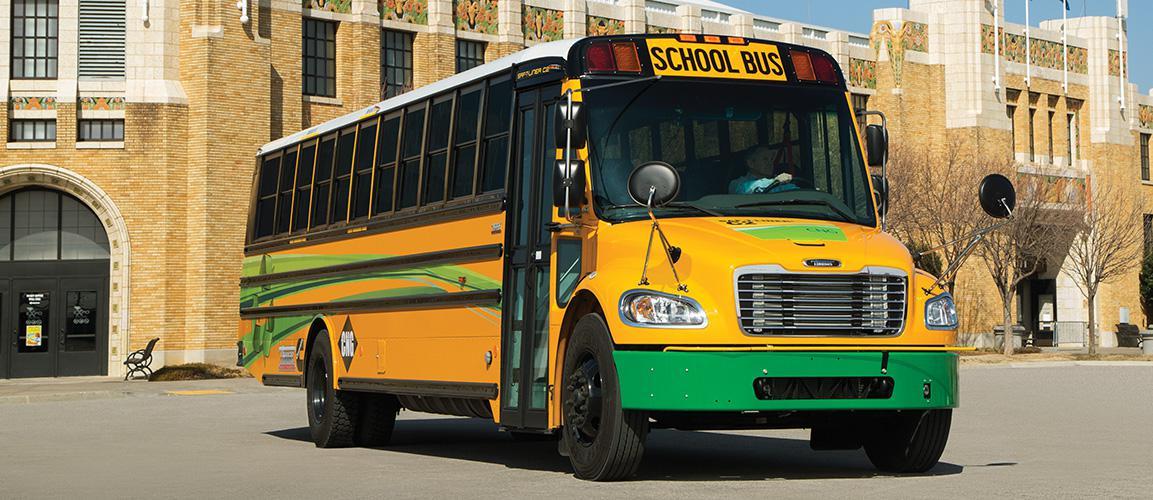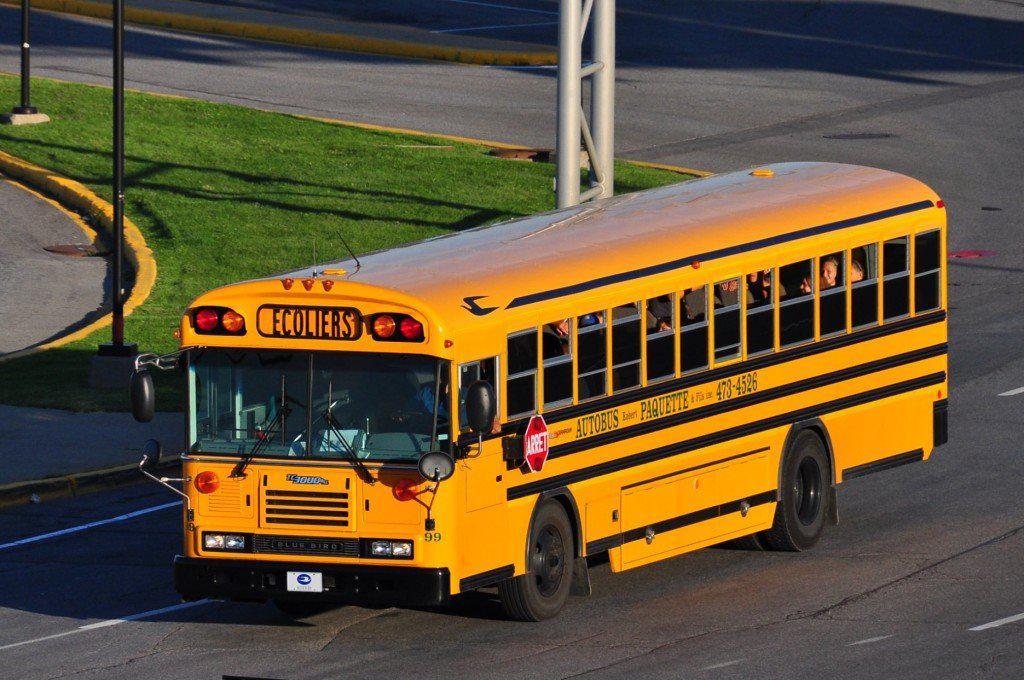The first image is the image on the left, the second image is the image on the right. Analyze the images presented: Is the assertion "Each image shows a single yellow bus with a nearly flat front, and the bus on the right is displayed at an angle but does not have a black stripe visible on its side." valid? Answer yes or no. No. The first image is the image on the left, the second image is the image on the right. Assess this claim about the two images: "there is a yellow school bus with a flat front and the stop sign visible". Correct or not? Answer yes or no. Yes. 